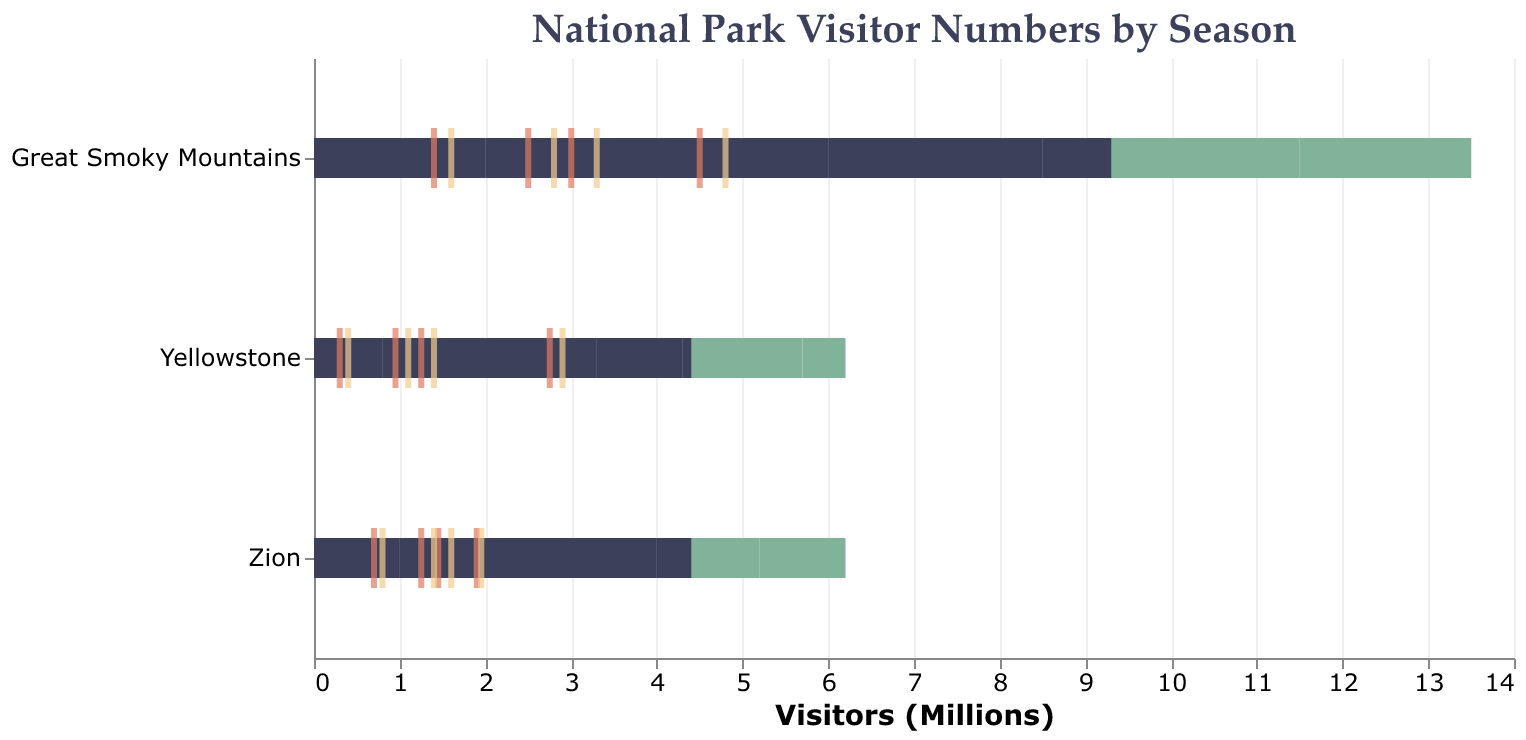What is the title of the figure? The title of the figure can be seen at the top of the chart. It states the main subject of the figure, which is visitor numbers to national parks, broken down by season.
Answer: National Park Visitor Numbers by Season How many parks are compared in this chart? By looking at the y-axis, which lists the names of the parks, we can count the number of different parks mentioned. The y-axis shows Yellowstone, Great Smoky Mountains, and Zion.
Answer: 3 In which season does the Great Smoky Mountains have the highest number of visitors? By examining the bars representing visitor numbers for the Great Smoky Mountains across different seasons, the tallest bar represents the highest number of visitors, which is in Summer.
Answer: Summer What is the capacity of Yellowstone in the Fall season? To find the capacity, we examine the length of the green bars for Yellowstone in the Fall season. The bar's length corresponds to 1.5 million visitors.
Answer: 1.5 million How does the visitor number in Zion during Winter compare to its capacity? In Winter, Zion's visitor number is represented by the dark bar, and its capacity by the green bar. The dark bar is shorter, indicating 400,000 visitors compared to the 1 million capacity.
Answer: Less than capacity Which park has the lowest number of visitors in Winter? In the Winter season, compare the dark bars' lengths for all parks. Yellowstone has the shortest bar indicating the lowest number of visitors, with 100,000 visitors.
Answer: Yellowstone How do the average visitors in Yellowstone in Spring compare to the goal? For Spring in Yellowstone, the average is denoted by an orange tick and the goal by a yellow tick. Compare their positions to see that the average is 0.95 million and the goal is 1.1 million.
Answer: Less than the goal What's the difference in visitor numbers between Spring and Fall at Great Smoky Mountains? For the Great Smoky Mountains, compare the lengths of the dark bars for Spring and Fall, indicating 2 million in Spring and 2.5 million in Fall. The difference is 2.5M - 2M.
Answer: 0.5 million In which season does Zion achieve its visitor goal most closely? Compare the yellow tick (goal) and the dark bar (visitors) for all seasons in Zion. In Summer, the dark bar (1.8 million) and yellow tick are closest, nearly matching the goal of 1.95 million.
Answer: Summer 